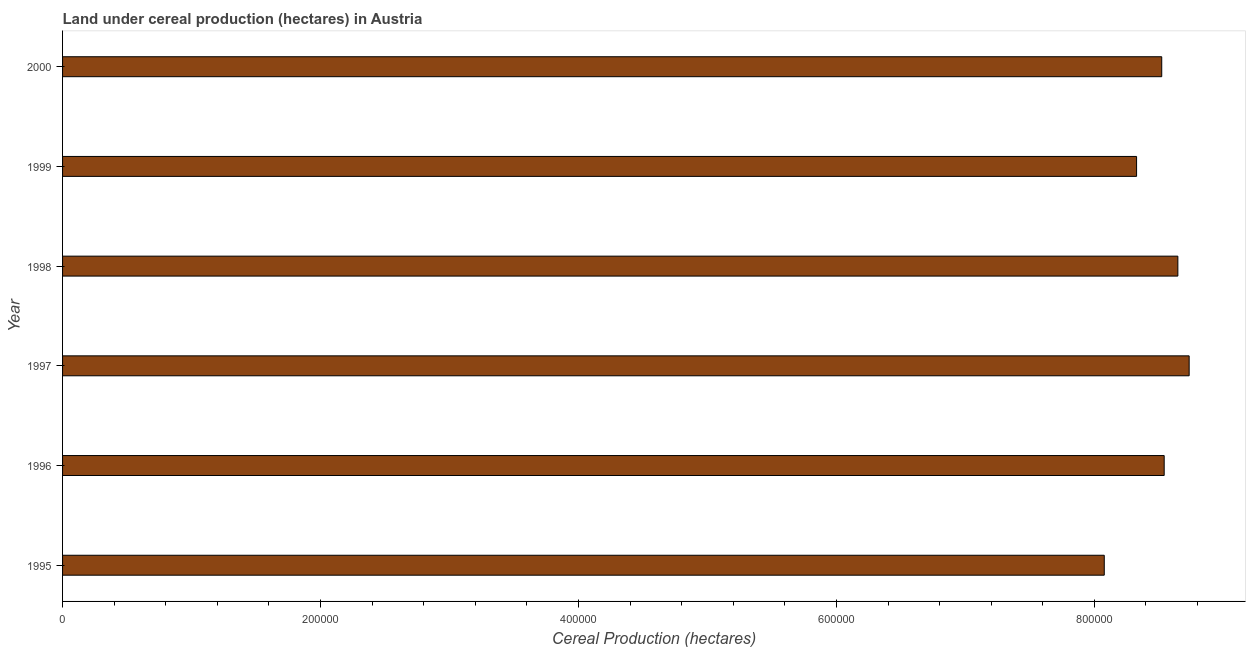Does the graph contain any zero values?
Provide a succinct answer. No. Does the graph contain grids?
Make the answer very short. No. What is the title of the graph?
Provide a succinct answer. Land under cereal production (hectares) in Austria. What is the label or title of the X-axis?
Provide a short and direct response. Cereal Production (hectares). What is the land under cereal production in 1998?
Give a very brief answer. 8.65e+05. Across all years, what is the maximum land under cereal production?
Provide a succinct answer. 8.73e+05. Across all years, what is the minimum land under cereal production?
Keep it short and to the point. 8.08e+05. In which year was the land under cereal production maximum?
Provide a succinct answer. 1997. What is the sum of the land under cereal production?
Your answer should be compact. 5.08e+06. What is the difference between the land under cereal production in 1998 and 2000?
Offer a very short reply. 1.25e+04. What is the average land under cereal production per year?
Your answer should be compact. 8.47e+05. What is the median land under cereal production?
Your response must be concise. 8.53e+05. In how many years, is the land under cereal production greater than 440000 hectares?
Provide a short and direct response. 6. Do a majority of the years between 1997 and 1996 (inclusive) have land under cereal production greater than 520000 hectares?
Make the answer very short. No. What is the ratio of the land under cereal production in 1998 to that in 1999?
Offer a very short reply. 1.04. Is the difference between the land under cereal production in 1999 and 2000 greater than the difference between any two years?
Give a very brief answer. No. What is the difference between the highest and the second highest land under cereal production?
Your answer should be very brief. 8763. What is the difference between the highest and the lowest land under cereal production?
Your answer should be very brief. 6.58e+04. How many bars are there?
Provide a succinct answer. 6. Are all the bars in the graph horizontal?
Your response must be concise. Yes. How many years are there in the graph?
Your answer should be compact. 6. What is the difference between two consecutive major ticks on the X-axis?
Keep it short and to the point. 2.00e+05. Are the values on the major ticks of X-axis written in scientific E-notation?
Provide a short and direct response. No. What is the Cereal Production (hectares) of 1995?
Keep it short and to the point. 8.08e+05. What is the Cereal Production (hectares) of 1996?
Ensure brevity in your answer.  8.54e+05. What is the Cereal Production (hectares) in 1997?
Your answer should be very brief. 8.73e+05. What is the Cereal Production (hectares) of 1998?
Your answer should be compact. 8.65e+05. What is the Cereal Production (hectares) in 1999?
Offer a terse response. 8.33e+05. What is the Cereal Production (hectares) of 2000?
Your response must be concise. 8.52e+05. What is the difference between the Cereal Production (hectares) in 1995 and 1996?
Your response must be concise. -4.65e+04. What is the difference between the Cereal Production (hectares) in 1995 and 1997?
Your answer should be very brief. -6.58e+04. What is the difference between the Cereal Production (hectares) in 1995 and 1998?
Give a very brief answer. -5.71e+04. What is the difference between the Cereal Production (hectares) in 1995 and 1999?
Your response must be concise. -2.51e+04. What is the difference between the Cereal Production (hectares) in 1995 and 2000?
Your response must be concise. -4.46e+04. What is the difference between the Cereal Production (hectares) in 1996 and 1997?
Your response must be concise. -1.94e+04. What is the difference between the Cereal Production (hectares) in 1996 and 1998?
Your answer should be very brief. -1.06e+04. What is the difference between the Cereal Production (hectares) in 1996 and 1999?
Provide a succinct answer. 2.14e+04. What is the difference between the Cereal Production (hectares) in 1996 and 2000?
Provide a short and direct response. 1893. What is the difference between the Cereal Production (hectares) in 1997 and 1998?
Give a very brief answer. 8763. What is the difference between the Cereal Production (hectares) in 1997 and 1999?
Your answer should be compact. 4.08e+04. What is the difference between the Cereal Production (hectares) in 1997 and 2000?
Offer a very short reply. 2.13e+04. What is the difference between the Cereal Production (hectares) in 1998 and 1999?
Your answer should be very brief. 3.20e+04. What is the difference between the Cereal Production (hectares) in 1998 and 2000?
Keep it short and to the point. 1.25e+04. What is the difference between the Cereal Production (hectares) in 1999 and 2000?
Offer a terse response. -1.95e+04. What is the ratio of the Cereal Production (hectares) in 1995 to that in 1996?
Provide a succinct answer. 0.95. What is the ratio of the Cereal Production (hectares) in 1995 to that in 1997?
Provide a short and direct response. 0.93. What is the ratio of the Cereal Production (hectares) in 1995 to that in 1998?
Your answer should be very brief. 0.93. What is the ratio of the Cereal Production (hectares) in 1995 to that in 2000?
Provide a succinct answer. 0.95. What is the ratio of the Cereal Production (hectares) in 1997 to that in 1999?
Offer a terse response. 1.05. What is the ratio of the Cereal Production (hectares) in 1997 to that in 2000?
Your answer should be very brief. 1.02. What is the ratio of the Cereal Production (hectares) in 1998 to that in 1999?
Provide a succinct answer. 1.04. What is the ratio of the Cereal Production (hectares) in 1998 to that in 2000?
Make the answer very short. 1.01. What is the ratio of the Cereal Production (hectares) in 1999 to that in 2000?
Your response must be concise. 0.98. 